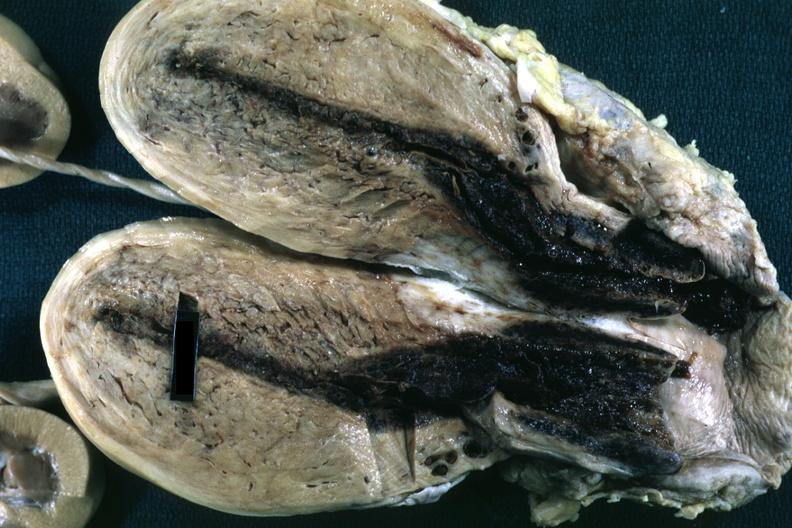where does this part belong to?
Answer the question using a single word or phrase. Female reproductive system 